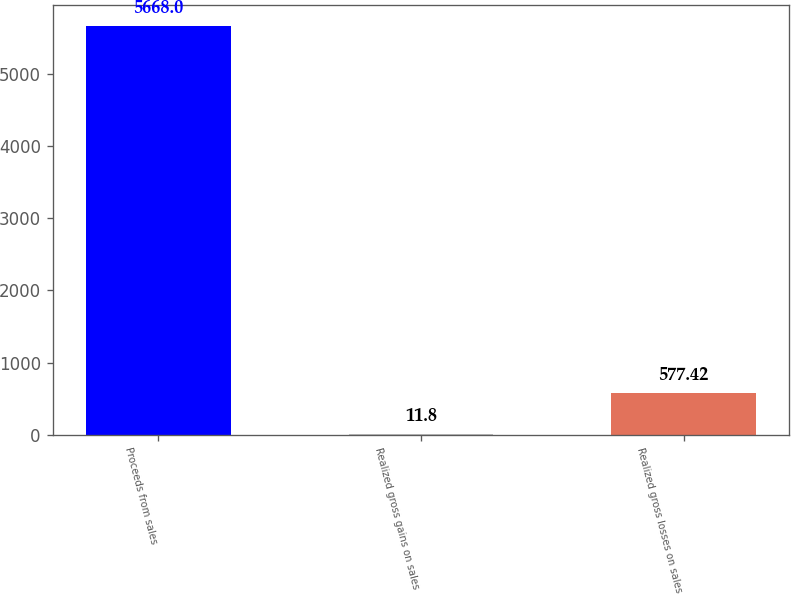<chart> <loc_0><loc_0><loc_500><loc_500><bar_chart><fcel>Proceeds from sales<fcel>Realized gross gains on sales<fcel>Realized gross losses on sales<nl><fcel>5668<fcel>11.8<fcel>577.42<nl></chart> 